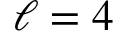Convert formula to latex. <formula><loc_0><loc_0><loc_500><loc_500>\ell = 4</formula> 